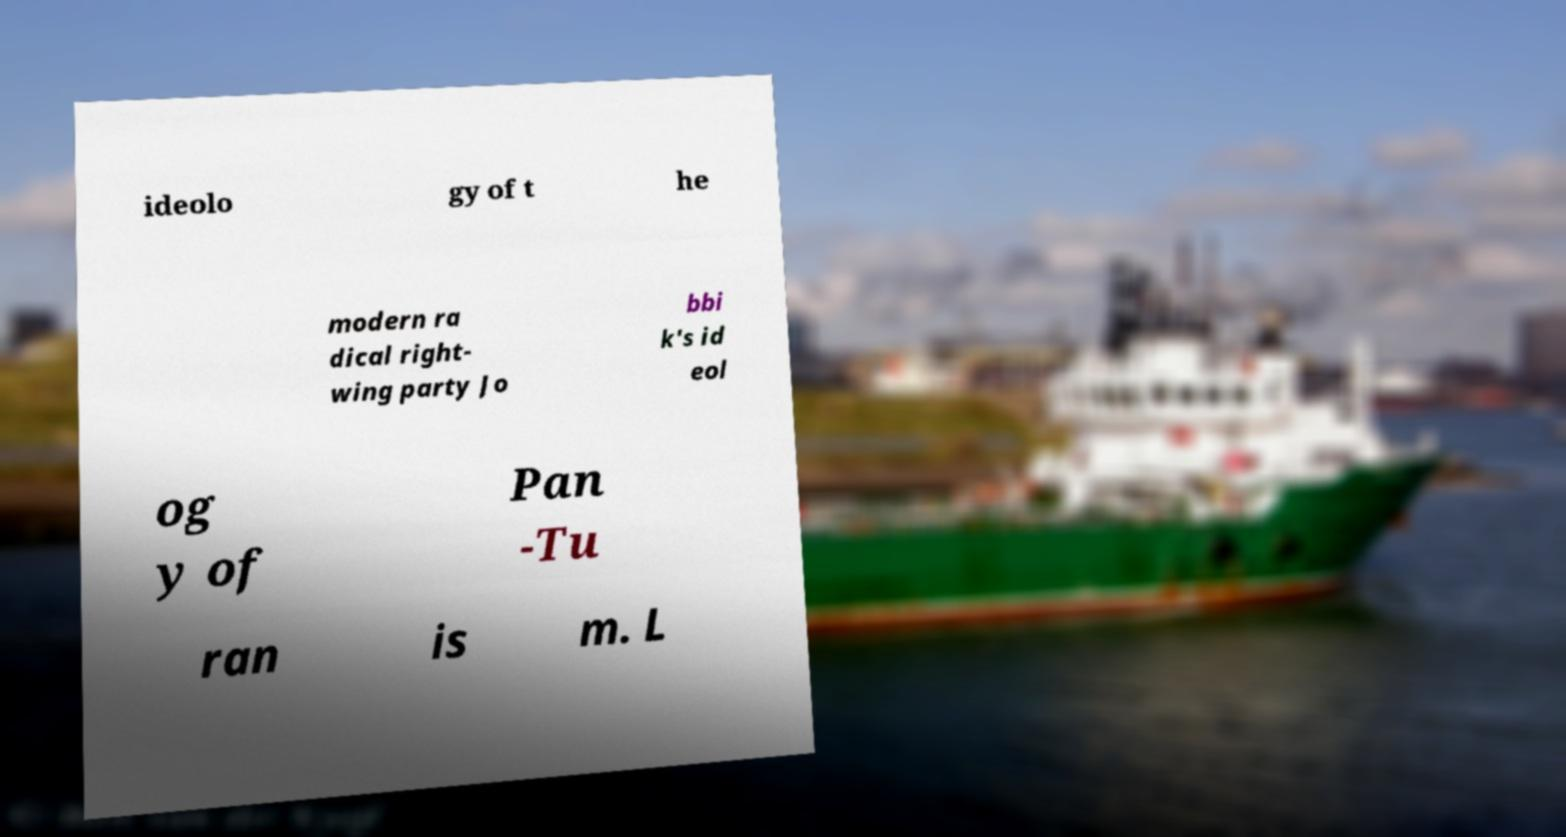Can you read and provide the text displayed in the image?This photo seems to have some interesting text. Can you extract and type it out for me? ideolo gy of t he modern ra dical right- wing party Jo bbi k's id eol og y of Pan -Tu ran is m. L 